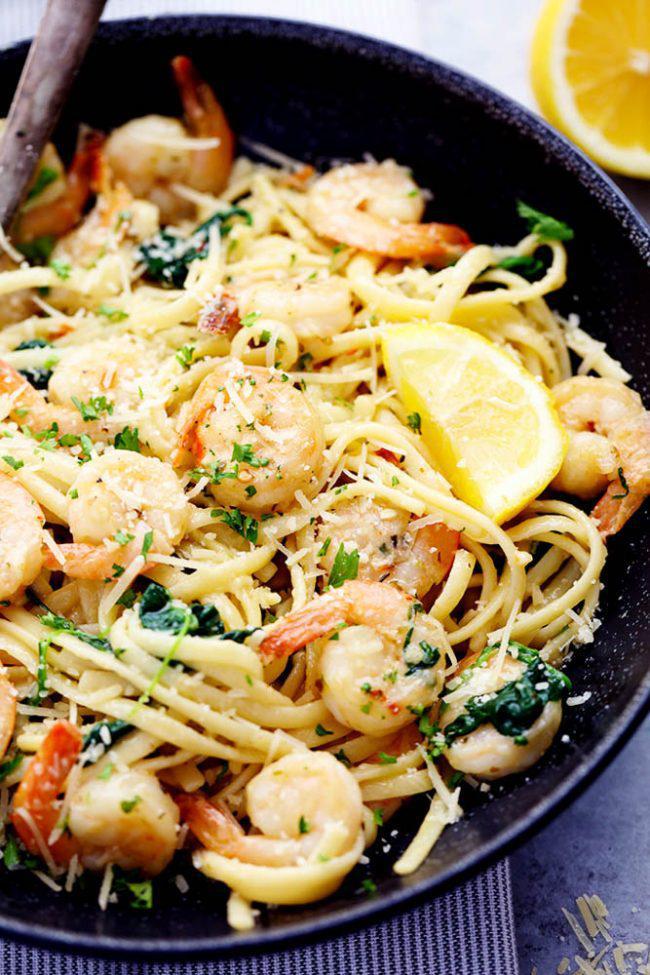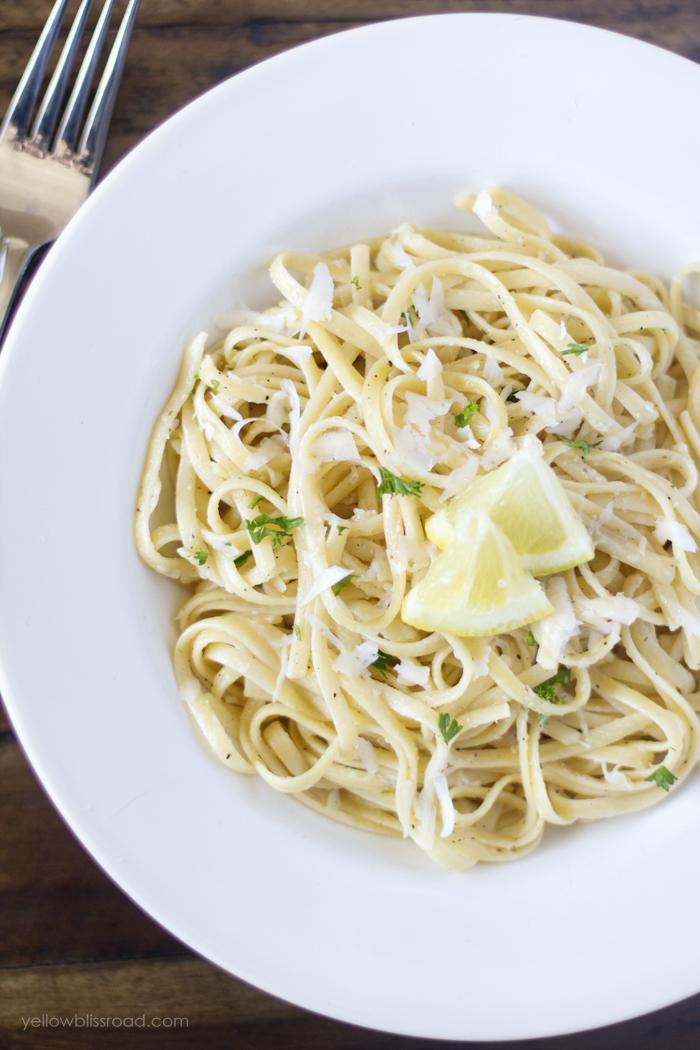The first image is the image on the left, the second image is the image on the right. For the images displayed, is the sentence "An image shows a slice of citrus fruit garnishing a white bowl of noodles on a checkered cloth." factually correct? Answer yes or no. No. 